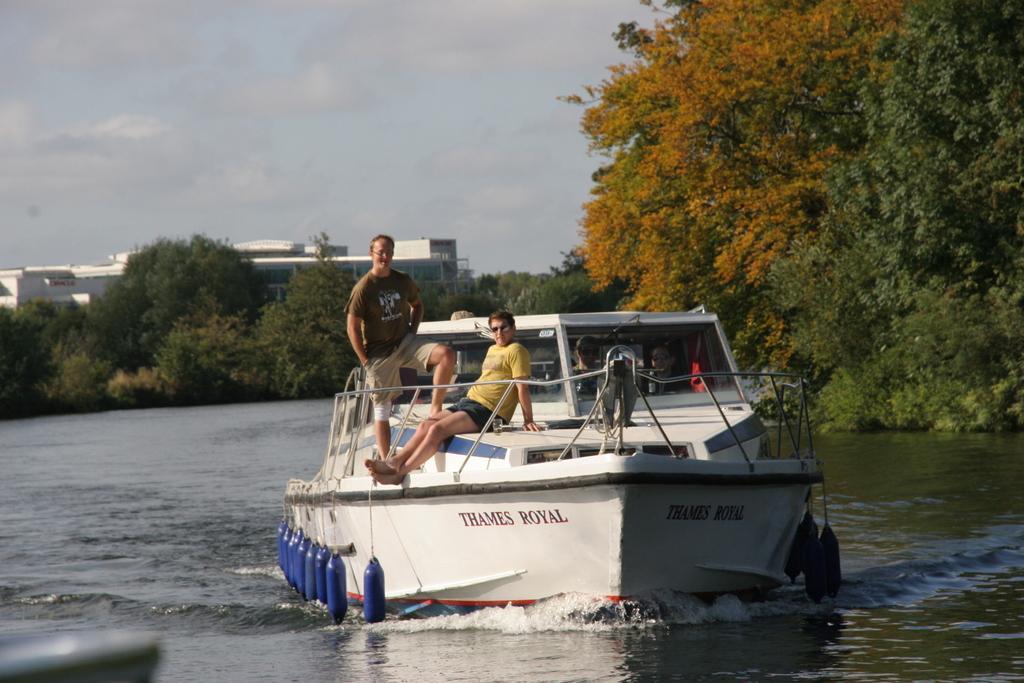Could you give a brief overview of what you see in this image? There is a white color boat on the water. On the boat there is a railing and some people are there. In the background there are trees, building and sky. 